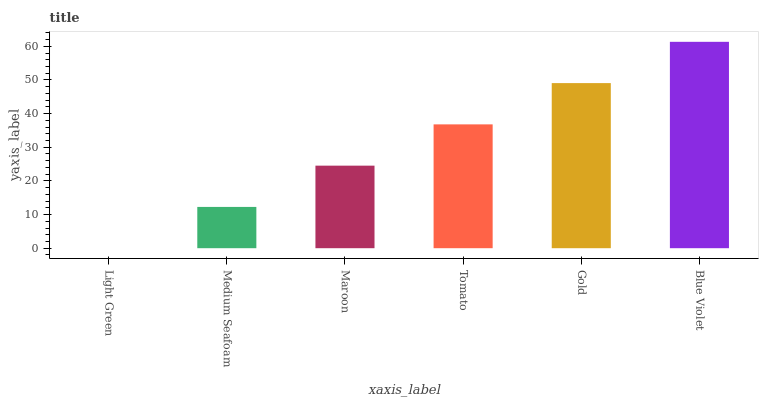Is Light Green the minimum?
Answer yes or no. Yes. Is Blue Violet the maximum?
Answer yes or no. Yes. Is Medium Seafoam the minimum?
Answer yes or no. No. Is Medium Seafoam the maximum?
Answer yes or no. No. Is Medium Seafoam greater than Light Green?
Answer yes or no. Yes. Is Light Green less than Medium Seafoam?
Answer yes or no. Yes. Is Light Green greater than Medium Seafoam?
Answer yes or no. No. Is Medium Seafoam less than Light Green?
Answer yes or no. No. Is Tomato the high median?
Answer yes or no. Yes. Is Maroon the low median?
Answer yes or no. Yes. Is Medium Seafoam the high median?
Answer yes or no. No. Is Gold the low median?
Answer yes or no. No. 